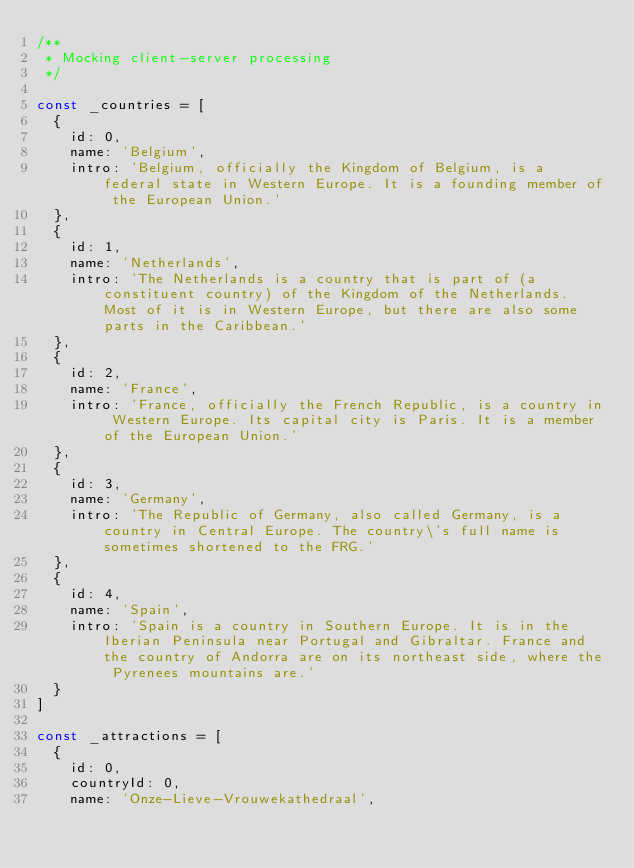<code> <loc_0><loc_0><loc_500><loc_500><_JavaScript_>/**
 * Mocking client-server processing
 */

const _countries = [
  {
    id: 0,
    name: 'Belgium',
    intro: 'Belgium, officially the Kingdom of Belgium, is a federal state in Western Europe. It is a founding member of the European Union.'
  },
  {
    id: 1,
    name: 'Netherlands',
    intro: 'The Netherlands is a country that is part of (a constituent country) of the Kingdom of the Netherlands. Most of it is in Western Europe, but there are also some parts in the Caribbean.'
  },
  {
    id: 2,
    name: 'France',
    intro: 'France, officially the French Republic, is a country in Western Europe. Its capital city is Paris. It is a member of the European Union.'
  },
  {
    id: 3,
    name: 'Germany',
    intro: 'The Republic of Germany, also called Germany, is a country in Central Europe. The country\'s full name is sometimes shortened to the FRG.'
  },
  {
    id: 4,
    name: 'Spain',
    intro: 'Spain is a country in Southern Europe. It is in the Iberian Peninsula near Portugal and Gibraltar. France and the country of Andorra are on its northeast side, where the Pyrenees mountains are.'
  }
]

const _attractions = [
  {
    id: 0,
    countryId: 0,
    name: 'Onze-Lieve-Vrouwekathedraal',</code> 